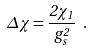<formula> <loc_0><loc_0><loc_500><loc_500>\Delta \chi = \frac { 2 \chi _ { 1 } } { g _ { s } ^ { 2 } } \ .</formula> 